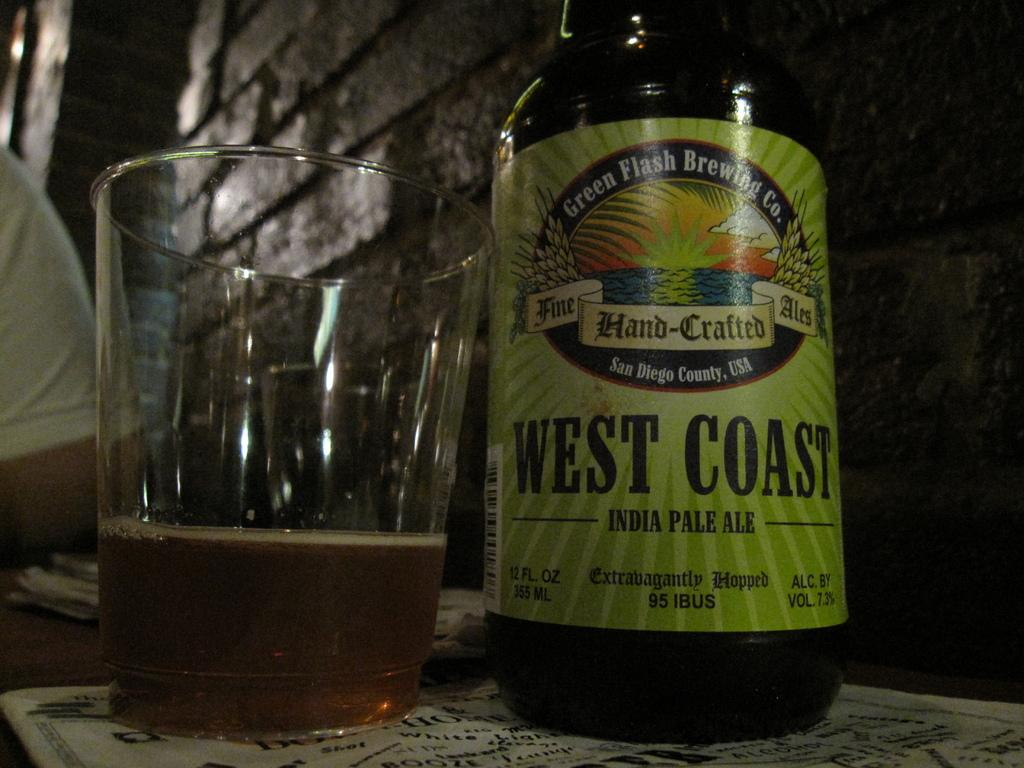<image>
Relay a brief, clear account of the picture shown. A bottle of West Coast India Pale Ale made by the Green Flash Brewing Co. 